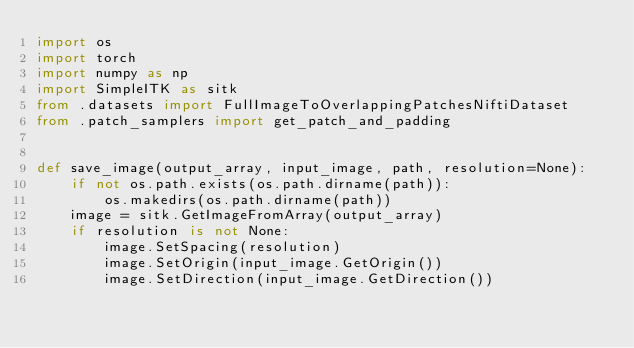<code> <loc_0><loc_0><loc_500><loc_500><_Python_>import os
import torch
import numpy as np
import SimpleITK as sitk
from .datasets import FullImageToOverlappingPatchesNiftiDataset
from .patch_samplers import get_patch_and_padding


def save_image(output_array, input_image, path, resolution=None):
    if not os.path.exists(os.path.dirname(path)):
        os.makedirs(os.path.dirname(path))
    image = sitk.GetImageFromArray(output_array)
    if resolution is not None:
        image.SetSpacing(resolution)
        image.SetOrigin(input_image.GetOrigin())
        image.SetDirection(input_image.GetDirection())</code> 